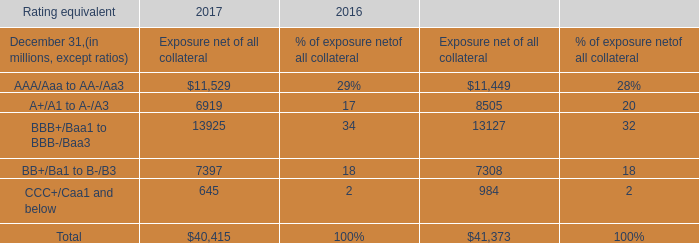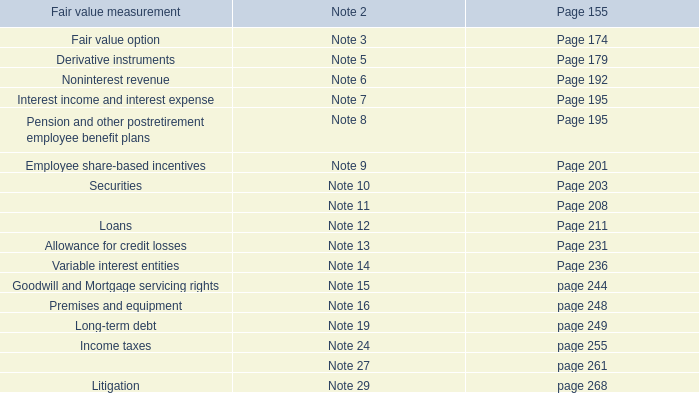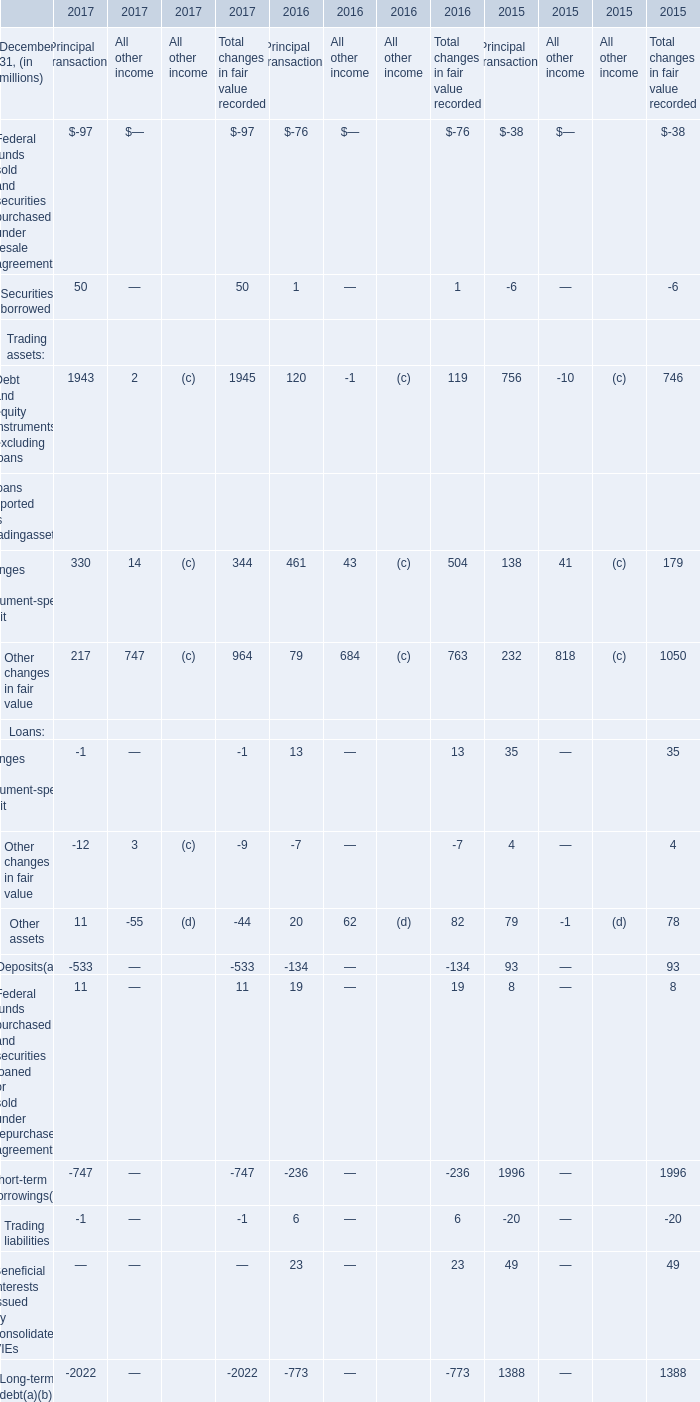What was the amount of the Other assets for Principal transactions in the year where the Long-term debt for Principal transactions is greater than 1000 million? (in million) 
Answer: 79. 